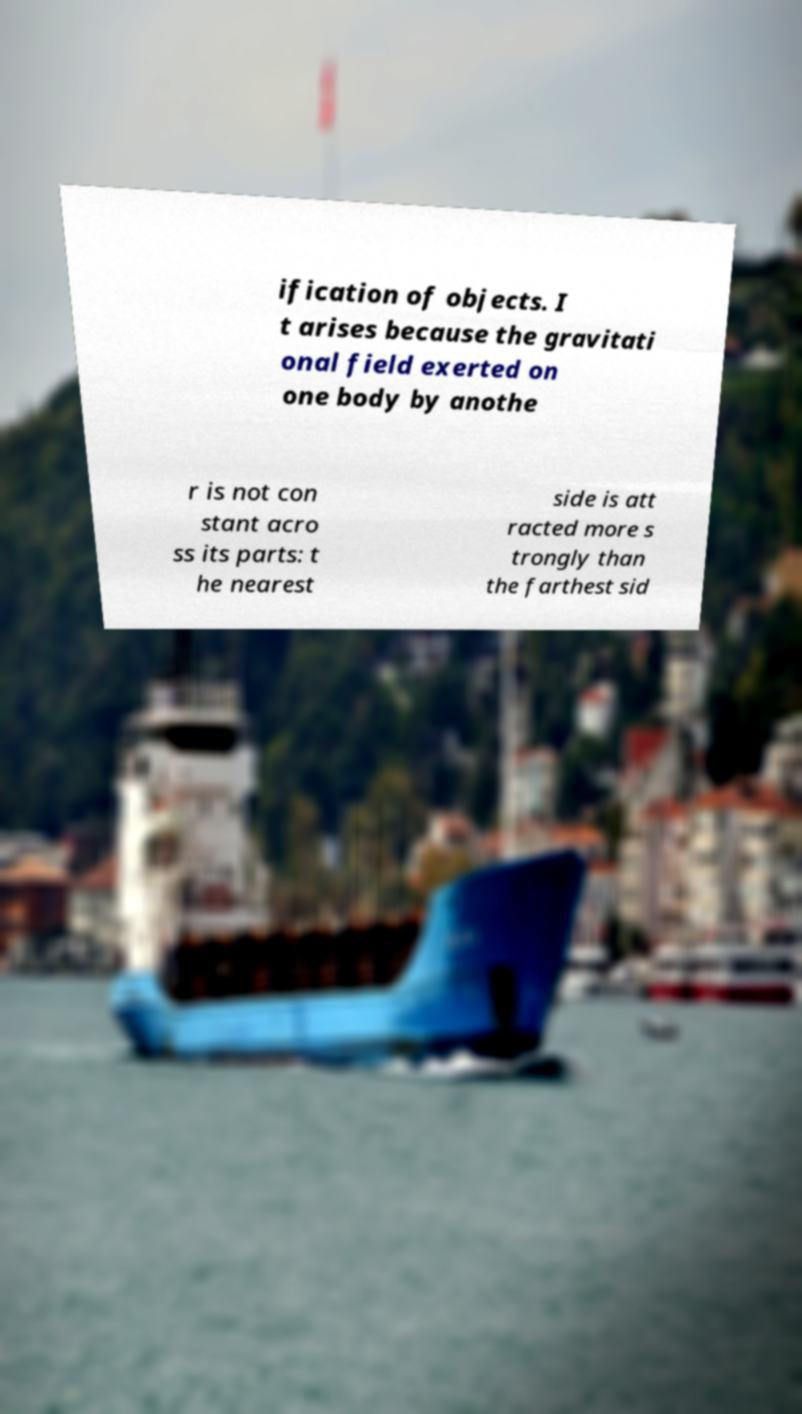Can you accurately transcribe the text from the provided image for me? ification of objects. I t arises because the gravitati onal field exerted on one body by anothe r is not con stant acro ss its parts: t he nearest side is att racted more s trongly than the farthest sid 